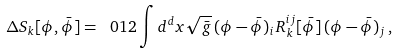<formula> <loc_0><loc_0><loc_500><loc_500>\Delta S _ { k } [ \phi , \bar { \phi } ] = \ 0 1 2 \int d ^ { d } x \sqrt { \bar { g } } \, ( \phi - \bar { \phi } ) _ { i } \, R _ { k } ^ { i j } [ \bar { \phi } ] \, ( \phi - \bar { \phi } ) _ { j } \, ,</formula> 